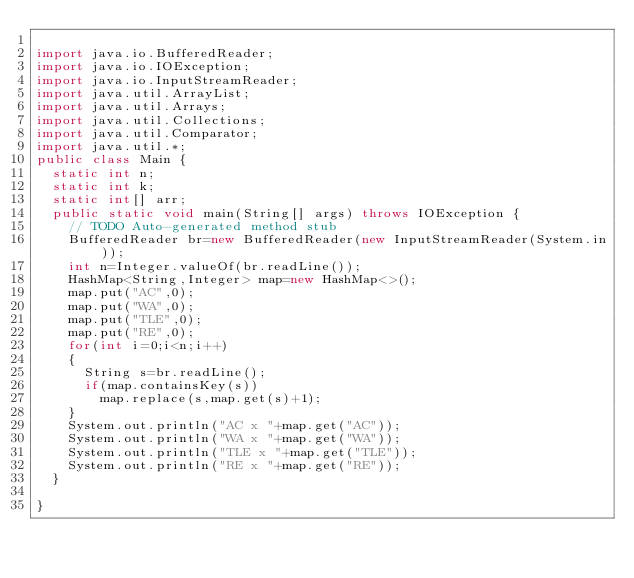<code> <loc_0><loc_0><loc_500><loc_500><_Java_>
import java.io.BufferedReader;
import java.io.IOException;
import java.io.InputStreamReader;
import java.util.ArrayList;
import java.util.Arrays;
import java.util.Collections;
import java.util.Comparator;
import java.util.*;
public class Main {
	static int n;
	static int k;
	static int[] arr;
	public static void main(String[] args) throws IOException {
		// TODO Auto-generated method stub
		BufferedReader br=new BufferedReader(new InputStreamReader(System.in));
		int n=Integer.valueOf(br.readLine());
		HashMap<String,Integer> map=new HashMap<>();
		map.put("AC",0);
		map.put("WA",0);
		map.put("TLE",0);
		map.put("RE",0);
		for(int i=0;i<n;i++)
		{
			String s=br.readLine();
			if(map.containsKey(s))
				map.replace(s,map.get(s)+1);
		}
		System.out.println("AC x "+map.get("AC"));
		System.out.println("WA x "+map.get("WA"));
		System.out.println("TLE x "+map.get("TLE"));
		System.out.println("RE x "+map.get("RE"));
	}

}
</code> 